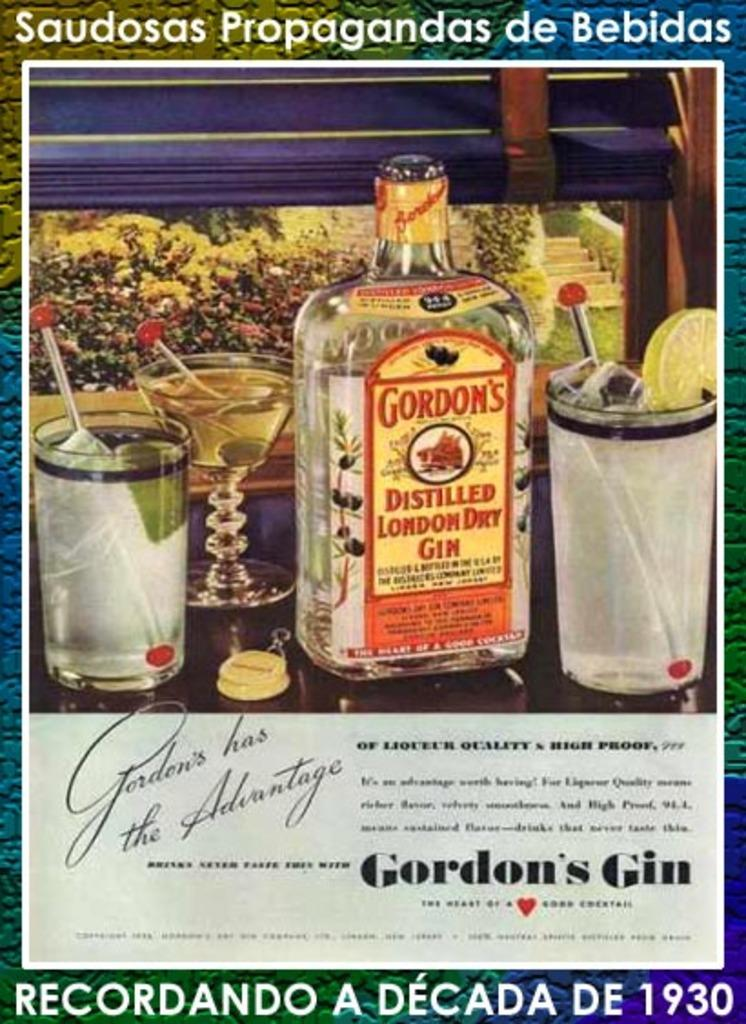<image>
Present a compact description of the photo's key features. An advertisement for Gordon's gin shows three different drinks one can make with it. 